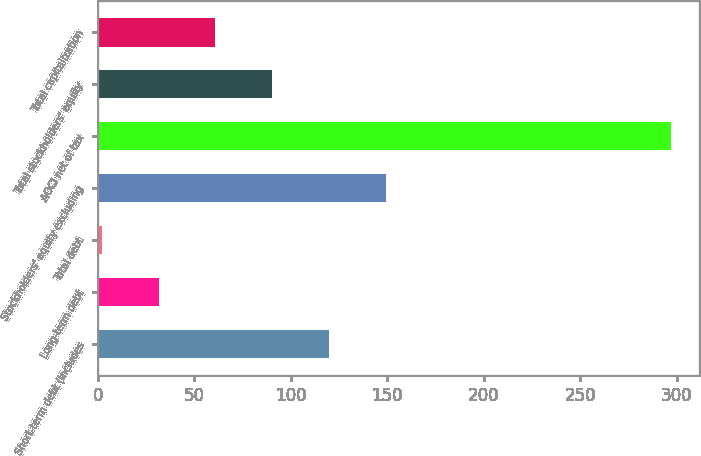Convert chart to OTSL. <chart><loc_0><loc_0><loc_500><loc_500><bar_chart><fcel>Short-term debt (includes<fcel>Long-term debt<fcel>Total debt<fcel>Stockholders' equity excluding<fcel>AOCI net of tax<fcel>Total stockholders' equity<fcel>Total capitalization<nl><fcel>120<fcel>31.5<fcel>2<fcel>149.5<fcel>297<fcel>90.5<fcel>61<nl></chart> 